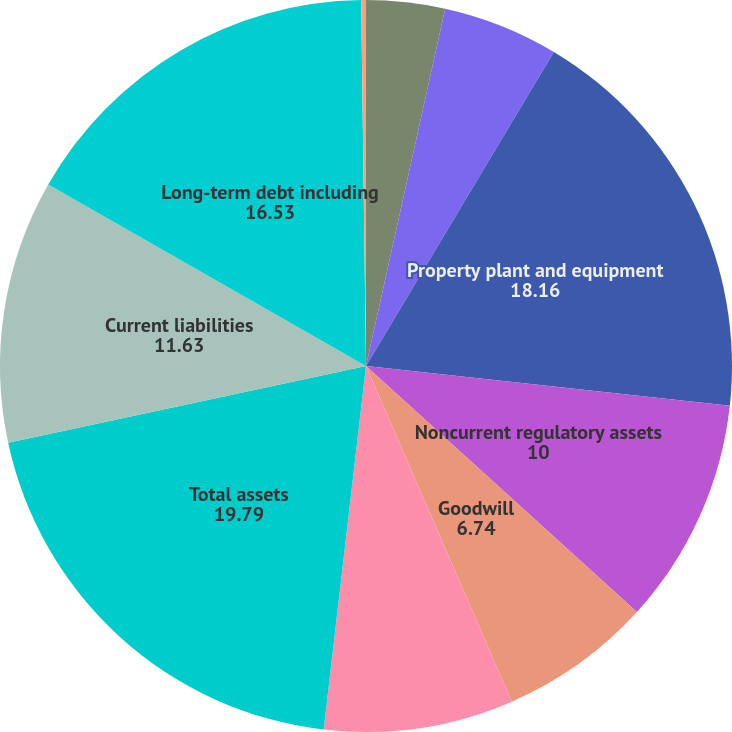Convert chart. <chart><loc_0><loc_0><loc_500><loc_500><pie_chart><fcel>in millions<fcel>Current assets<fcel>Property plant and equipment<fcel>Noncurrent regulatory assets<fcel>Goodwill<fcel>Other deferred debits and<fcel>Total assets<fcel>Current liabilities<fcel>Long-term debt including<fcel>Regulatory liabilities<nl><fcel>3.47%<fcel>5.11%<fcel>18.16%<fcel>10.0%<fcel>6.74%<fcel>8.37%<fcel>19.79%<fcel>11.63%<fcel>16.53%<fcel>0.21%<nl></chart> 